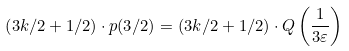<formula> <loc_0><loc_0><loc_500><loc_500>\left ( 3 k / 2 + 1 / 2 \right ) \cdot p ( 3 / 2 ) = \left ( 3 k / 2 + 1 / 2 \right ) \cdot Q \left ( \frac { 1 } { 3 \varepsilon } \right )</formula> 